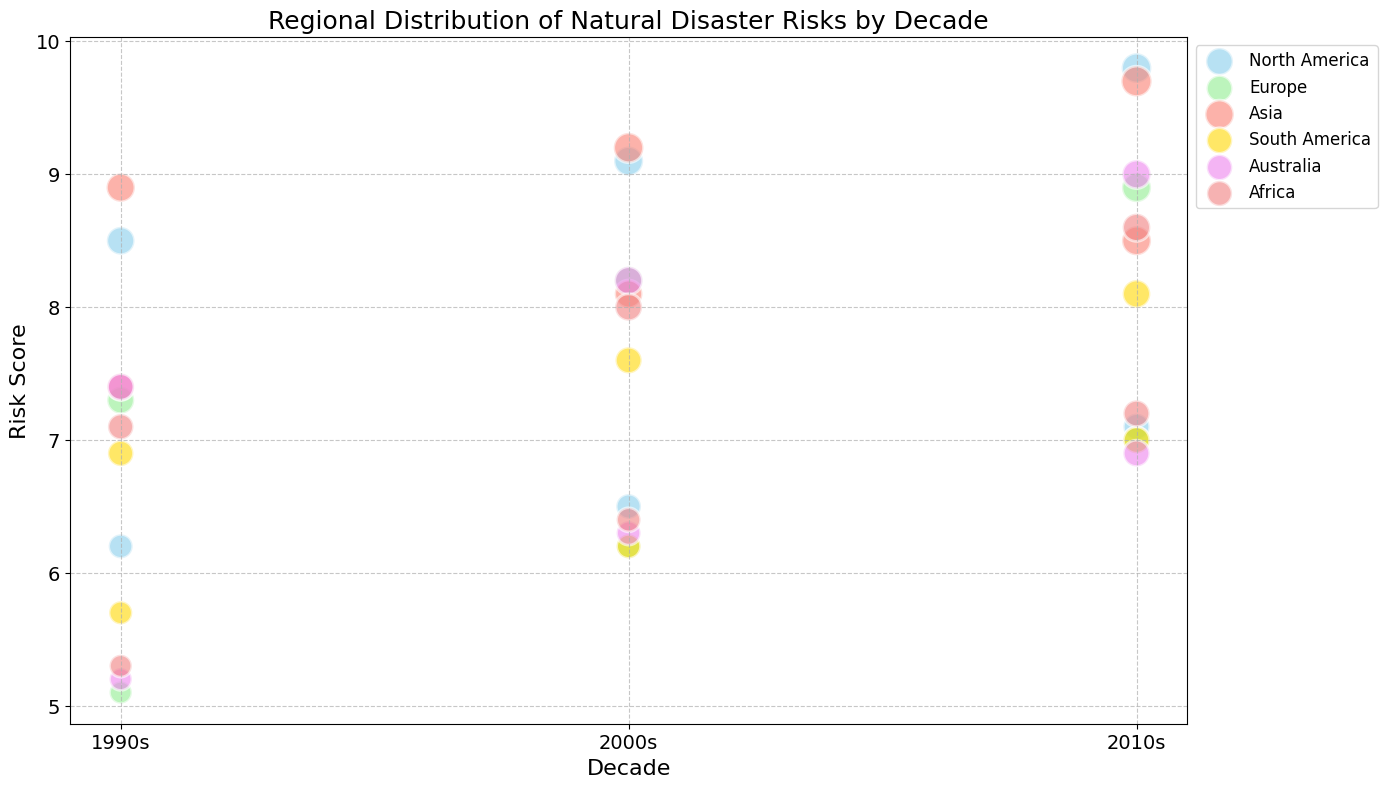What is the Risk Score range for Earthquakes in North America across the decades? First, identify the Risk Scores for Earthquakes in North America from the figure. They are 6.2 in the 1990s, 6.5 in the 2000s, and 6.5 in the 2010s. The range is the difference between the highest (6.5) and the lowest (6.2) scores.
Answer: 0.3 Which region had the highest Risk Score for any natural disaster in the 2000s? From the figure, examine the maximum Risk Scores for each region in the 2000s. North America had a highest score of 9.1 for Hurricanes. Compare this with other regions: Europe (8.2), Asia (9.2), South America (7.6), Australia (8.2), and Africa (8.0). So, Asia has the highest score.
Answer: Asia Between Europe and Australia, which region saw a larger increase in Flood Risk Scores from the 1990s to the 2010s? Identify the Flood Risk Scores for both regions in the 1990s and 2010s: Europe (7.3 to 8.9), Australia (5.2 to 6.9). Calculate the increase for each: Europe (8.9 - 7.3 = 1.6), Australia (6.9 - 5.2 = 1.7). Compare the increases: 1.6 vs 1.7.
Answer: Australia Which decade had the highest average Risk Score for disasters in South America? Locate the Risk Scores for South America by decade: 1990s (6.9, 5.7), 2000s (7.6, 6.2), 2010s (8.1, 7.0). Calculate the average for each decade: 1990s ( (6.9 + 5.7) / 2 = 6.3), 2000s ( (7.6 + 6.2) / 2 = 6.9), 2010s ( (8.1 + 7.0) / 2 = 7.55). Compare the averages: 6.3, 6.9, 7.55.
Answer: 2010s What is the size difference between the largest and smallest bubbles for disasters in Africa? Identify the bubble sizes for Africa across decades: 1990s (17, 13), 2000s (19, 15), 2010s (20, 18). The largest size is 20 and the smallest is 13. The size difference is 20 - 13.
Answer: 7 How did the Risk Score for Typhoons in Asia change from the 1990s to the 2010s? Refer to the figure for the Risk Scores for Typhoons in Asia: 1990s (7.4), 2000s (8.1), and 2010s (8.5). Calculate the difference between the 2010s and the 1990s: 8.5 - 7.4.
Answer: 1.1 Among all regions, which natural disaster had the highest recorded Risk Score in the 2010s? Identify the highest Risk Scores for each region and disaster type in the 2010s: North America (9.8 for Hurricanes), Europe (8.9 for Floods), Asia (9.7 for Earthquakes), South America (8.1 for Floods), Australia (9.0 for Bushfires), Africa (8.6 for Droughts). The highest score overall is 9.8 for Hurricanes in North America.
Answer: Hurricanes in North America 